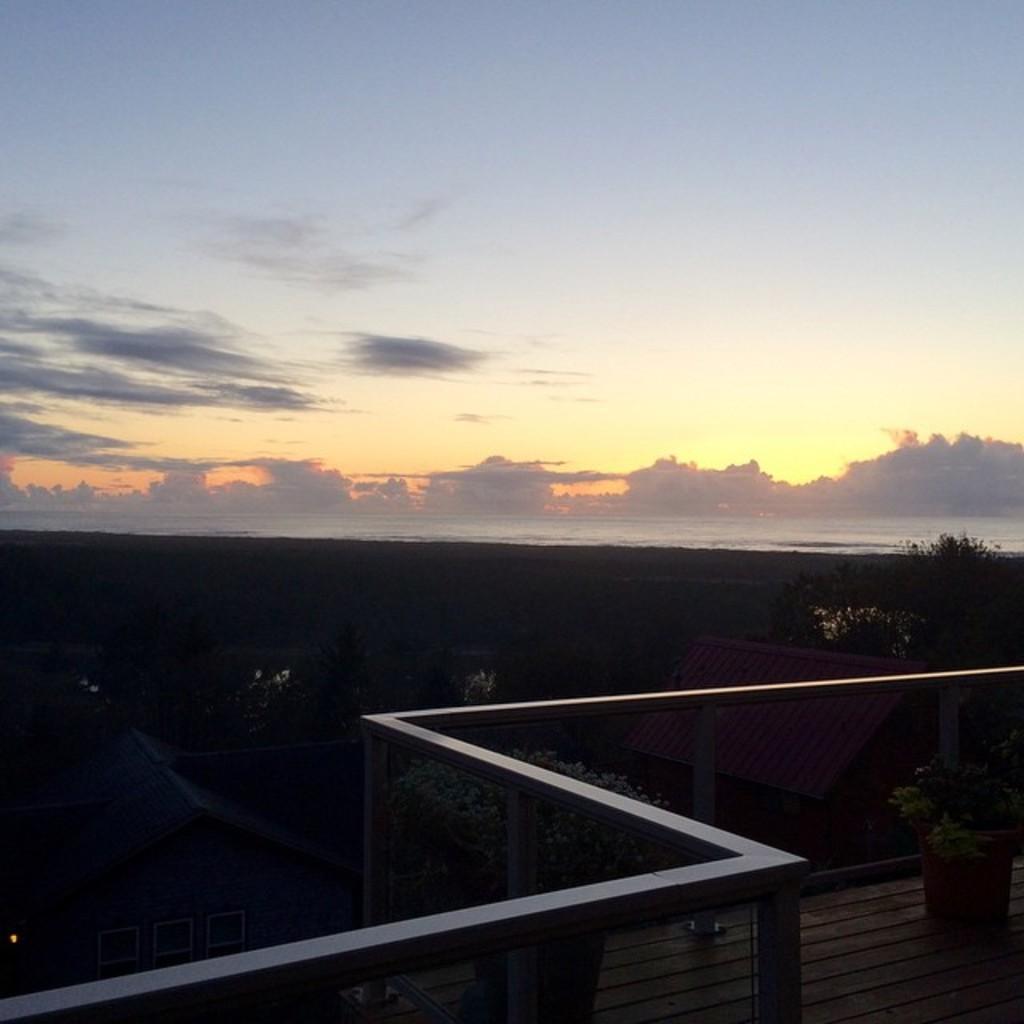Describe this image in one or two sentences. In this image I can see the railing, few trees, the roof which is red in color and in the background I can see the water, few trees and the sky. 